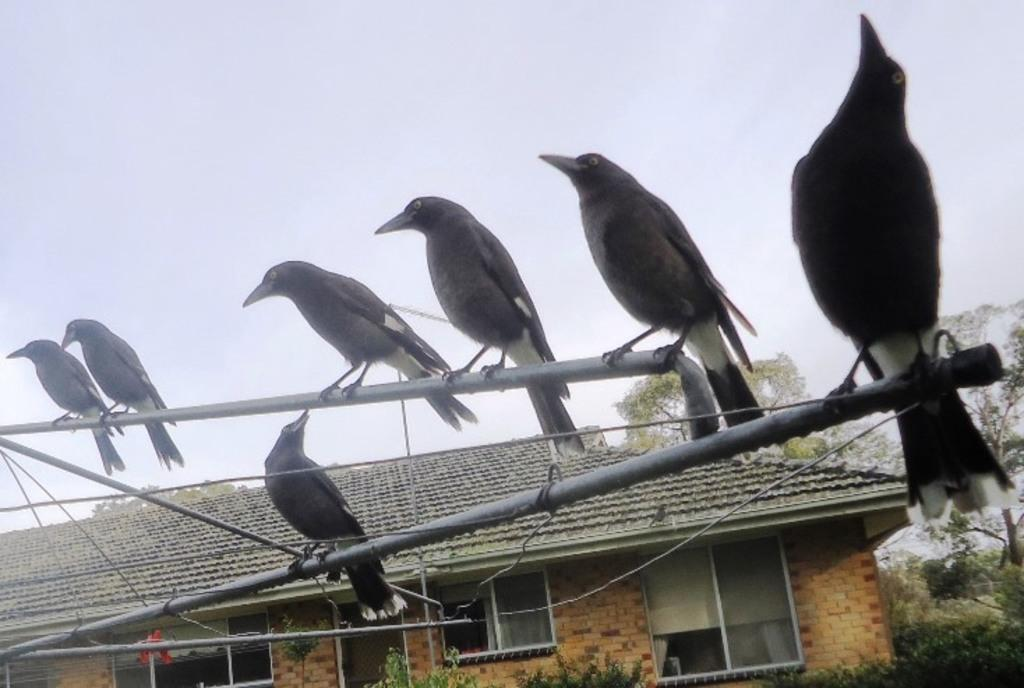What animals are present in the image? There is a group of crows in the image. Where are the crows located? The crows are sitting on a pole. What can be seen in the background of the image? There is a house in the background of the image. What type of vegetation is on the right side of the image? There are trees on the right side of the image. What is visible in the sky? There are clouds in the sky. What type of drug is the secretary using in the image? There is no secretary or drug present in the image; it features a group of crows sitting on a pole. What type of knife is visible in the image? There is no knife present in the image. 